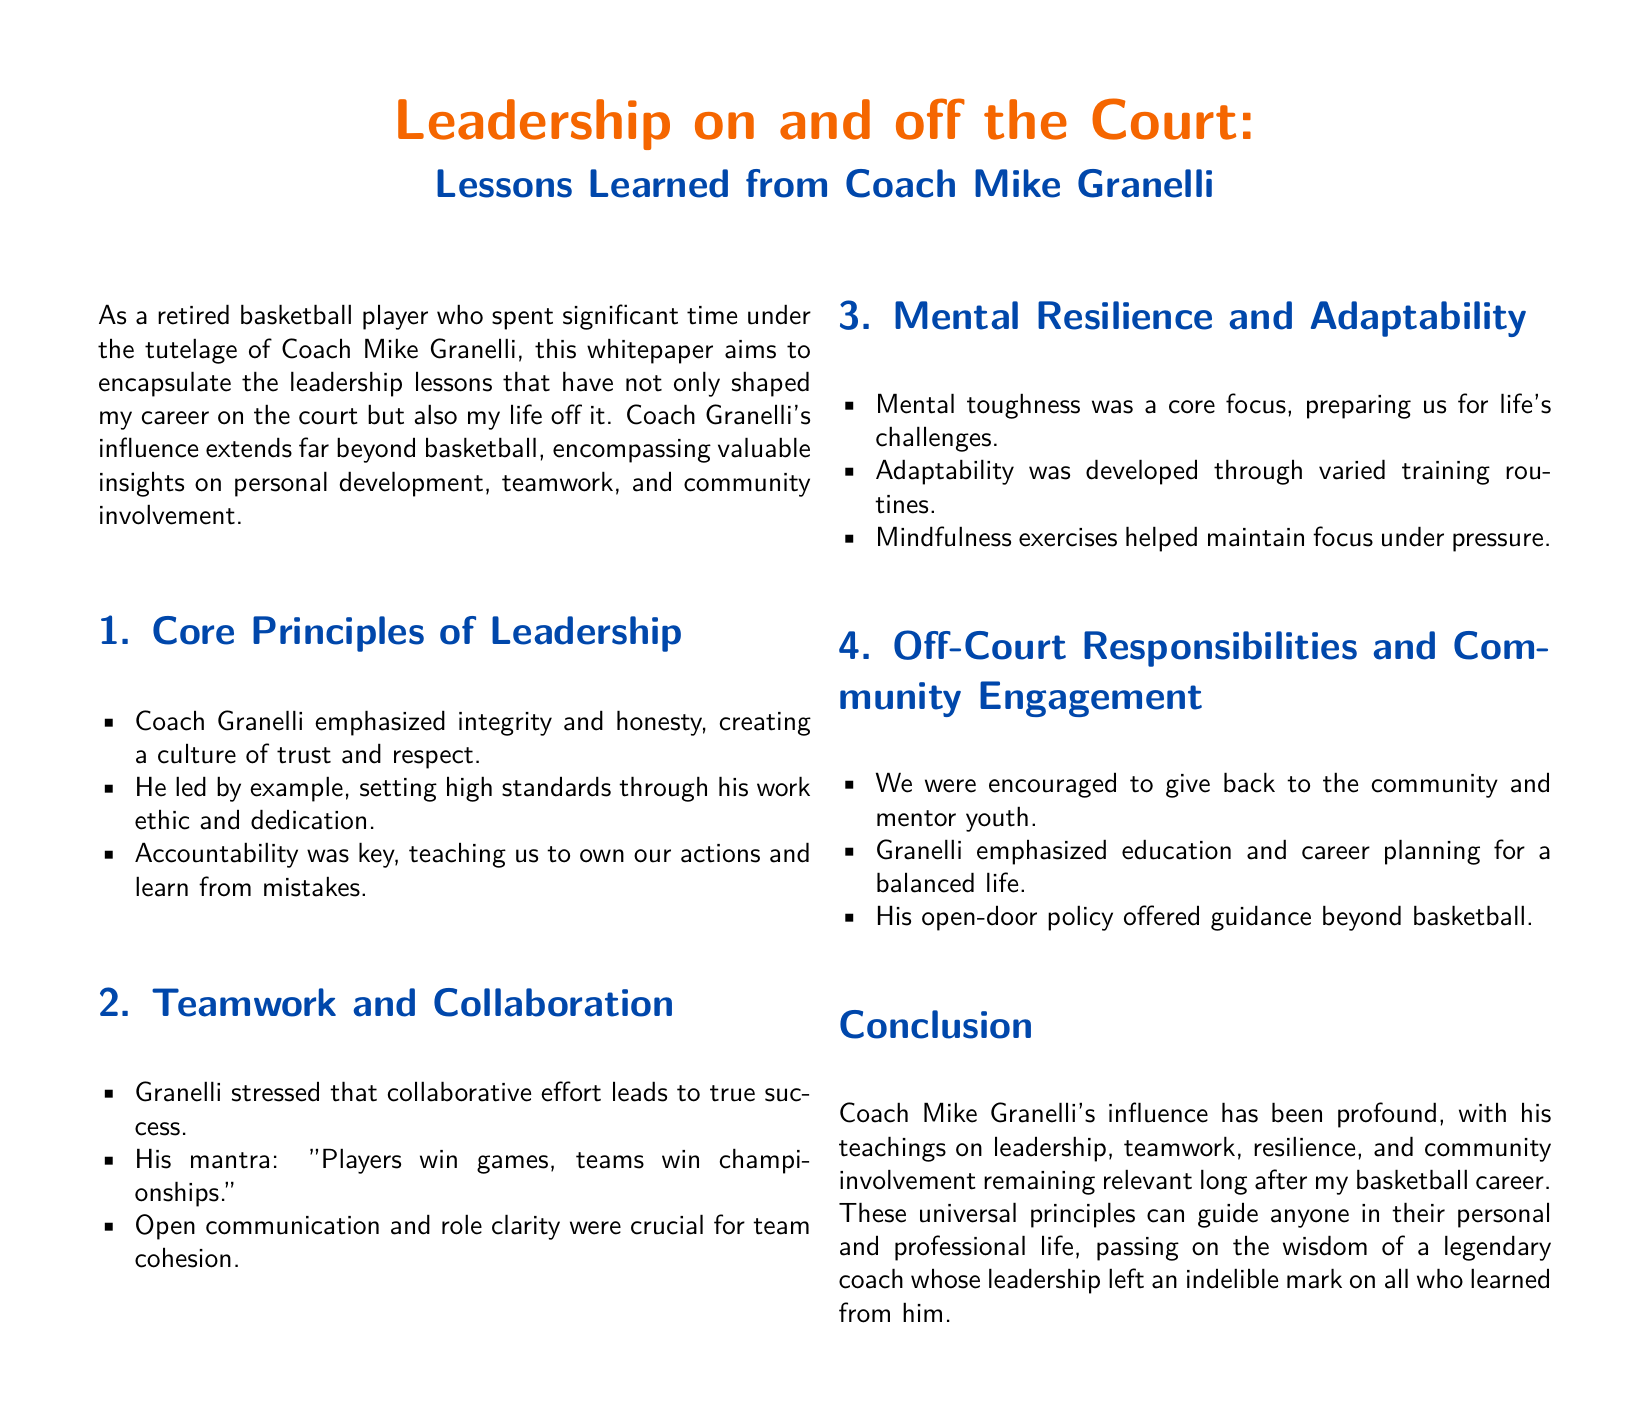what is the title of the whitepaper? The title is presented at the beginning of the document, which outlines the focus on leadership lessons learned from Coach Mike Granelli.
Answer: Leadership on and off the Court: Lessons Learned from Coach Mike Granelli who is the main figure discussed in the document? The document centers around the insights and teachings of a specific individual who was a coach during the author's career.
Answer: Coach Mike Granelli what mantra did Coach Granelli emphasize regarding teamwork? The mantra is a key principle cited in the teamwork section, highlighting the importance of collective effort over individual achievements.
Answer: Players win games, teams win championships how many sections are in the document? The structure of the document divides the content into distinct sections, which can be counted to determine the total number.
Answer: Four what core principle focused on accountability? The core principles section addresses various attributes of leadership, specifically highlighting the importance of taking ownership of actions.
Answer: Accountability which responsibility does the document associate with off-court activities? The off-court responsibilities section discusses the importance of community involvement and the broader impact players should have beyond basketball.
Answer: Community engagement what is a key theme of mental resilience as described? The section on mental resilience discusses how the individuals were prepared for life's challenges through specific methods and exercises.
Answer: Mental toughness how does the author feel about Coach Granelli's influence? The conclusion of the document encapsulates the author's sentiments regarding the lasting impact of Coach Granelli's teachings in various aspects of life.
Answer: Profound 